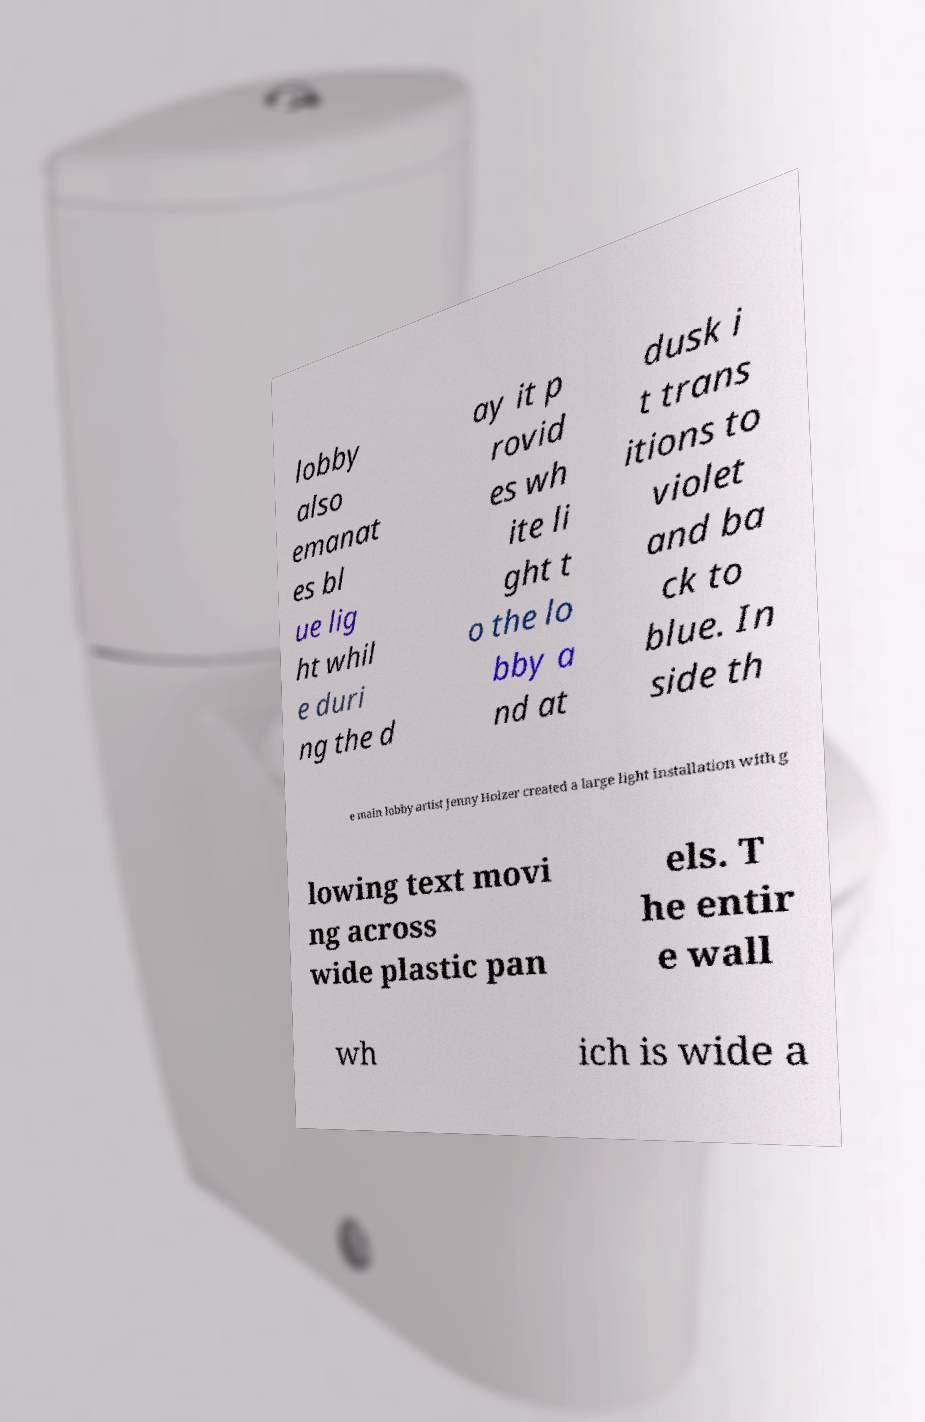Can you read and provide the text displayed in the image?This photo seems to have some interesting text. Can you extract and type it out for me? lobby also emanat es bl ue lig ht whil e duri ng the d ay it p rovid es wh ite li ght t o the lo bby a nd at dusk i t trans itions to violet and ba ck to blue. In side th e main lobby artist Jenny Holzer created a large light installation with g lowing text movi ng across wide plastic pan els. T he entir e wall wh ich is wide a 